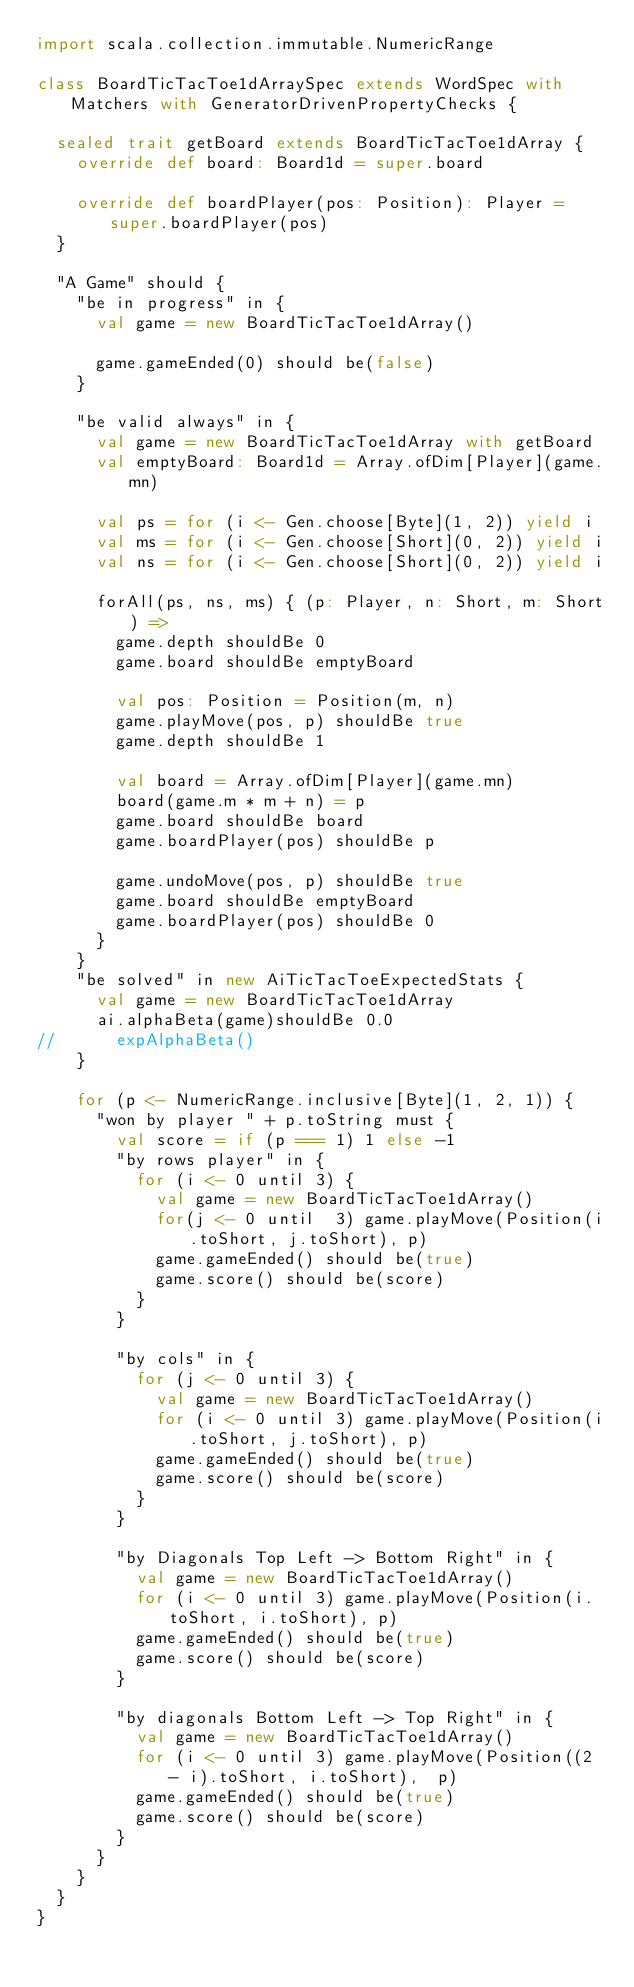Convert code to text. <code><loc_0><loc_0><loc_500><loc_500><_Scala_>import scala.collection.immutable.NumericRange

class BoardTicTacToe1dArraySpec extends WordSpec with Matchers with GeneratorDrivenPropertyChecks {

  sealed trait getBoard extends BoardTicTacToe1dArray {
    override def board: Board1d = super.board

    override def boardPlayer(pos: Position): Player = super.boardPlayer(pos)
  }

  "A Game" should {
    "be in progress" in {
      val game = new BoardTicTacToe1dArray()

      game.gameEnded(0) should be(false)
    }

    "be valid always" in {
      val game = new BoardTicTacToe1dArray with getBoard
      val emptyBoard: Board1d = Array.ofDim[Player](game.mn)

      val ps = for (i <- Gen.choose[Byte](1, 2)) yield i
      val ms = for (i <- Gen.choose[Short](0, 2)) yield i
      val ns = for (i <- Gen.choose[Short](0, 2)) yield i

      forAll(ps, ns, ms) { (p: Player, n: Short, m: Short) =>
        game.depth shouldBe 0
        game.board shouldBe emptyBoard

        val pos: Position = Position(m, n)
        game.playMove(pos, p) shouldBe true
        game.depth shouldBe 1

        val board = Array.ofDim[Player](game.mn)
        board(game.m * m + n) = p
        game.board shouldBe board
        game.boardPlayer(pos) shouldBe p

        game.undoMove(pos, p) shouldBe true
        game.board shouldBe emptyBoard
        game.boardPlayer(pos) shouldBe 0
      }
    }
    "be solved" in new AiTicTacToeExpectedStats {
      val game = new BoardTicTacToe1dArray
      ai.alphaBeta(game)shouldBe 0.0
//      expAlphaBeta()
    }

    for (p <- NumericRange.inclusive[Byte](1, 2, 1)) {
      "won by player " + p.toString must {
        val score = if (p === 1) 1 else -1
        "by rows player" in {
          for (i <- 0 until 3) {
            val game = new BoardTicTacToe1dArray()
            for(j <- 0 until  3) game.playMove(Position(i.toShort, j.toShort), p)
            game.gameEnded() should be(true)
            game.score() should be(score)
          }
        }

        "by cols" in {
          for (j <- 0 until 3) {
            val game = new BoardTicTacToe1dArray()
            for (i <- 0 until 3) game.playMove(Position(i.toShort, j.toShort), p)
            game.gameEnded() should be(true)
            game.score() should be(score)
          }
        }

        "by Diagonals Top Left -> Bottom Right" in {
          val game = new BoardTicTacToe1dArray()
          for (i <- 0 until 3) game.playMove(Position(i.toShort, i.toShort), p)
          game.gameEnded() should be(true)
          game.score() should be(score)
        }

        "by diagonals Bottom Left -> Top Right" in {
          val game = new BoardTicTacToe1dArray()
          for (i <- 0 until 3) game.playMove(Position((2 - i).toShort, i.toShort),  p)
          game.gameEnded() should be(true)
          game.score() should be(score)
        }
      }
    }
  }
}
</code> 